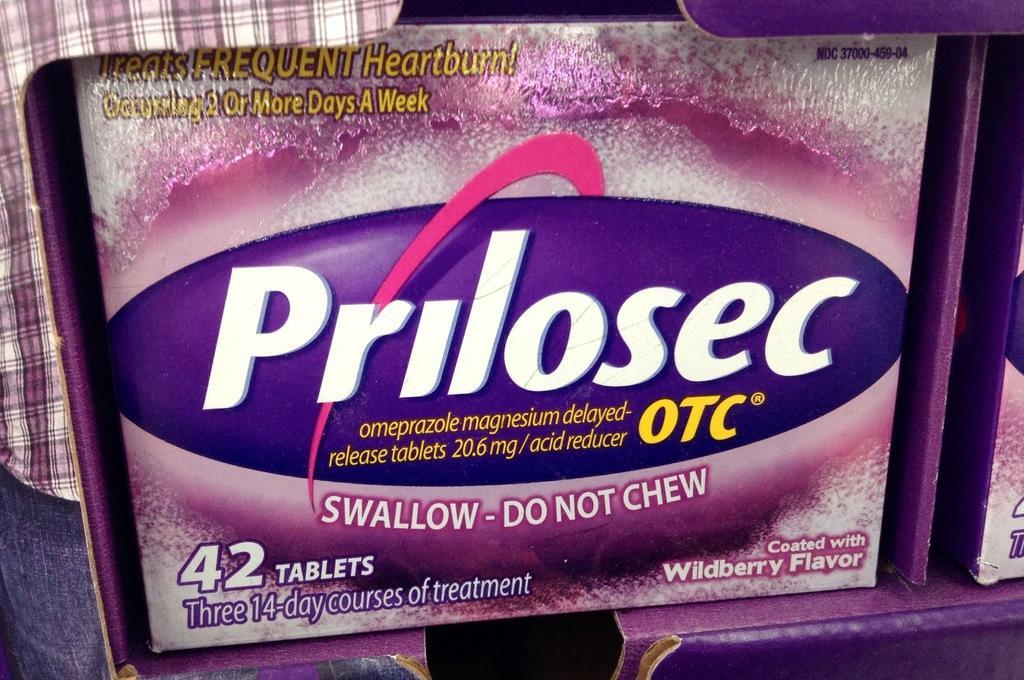Could you give a brief overview of what you see in this image? In this image there is a box with some text and numbers written on it and there are objects which are pink in colour. 